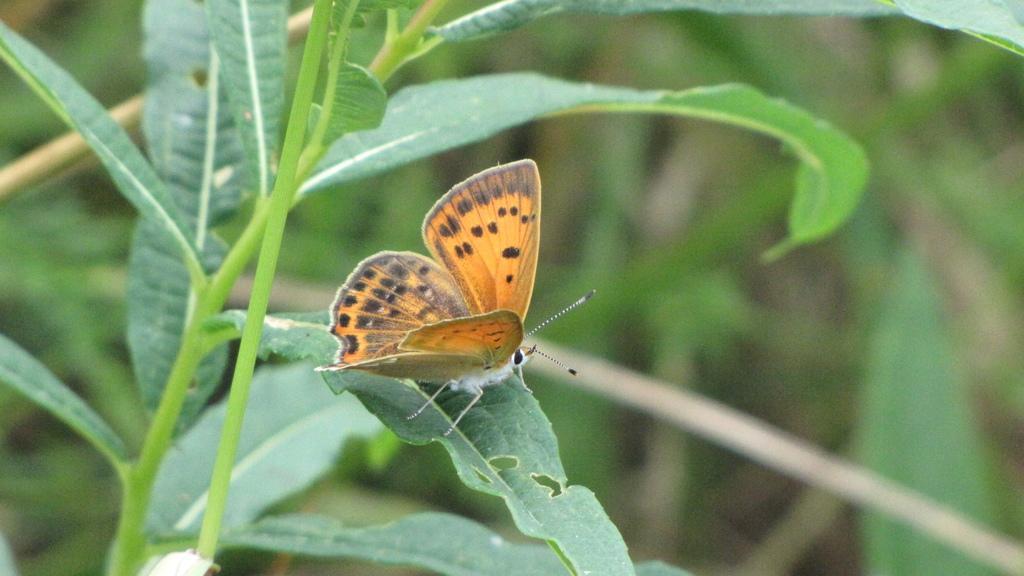Could you give a brief overview of what you see in this image? In this picture I can see the green leaves and in the middle of this picture I can see a butterfly which is of black and orange color. I see that it is green color in the background. 